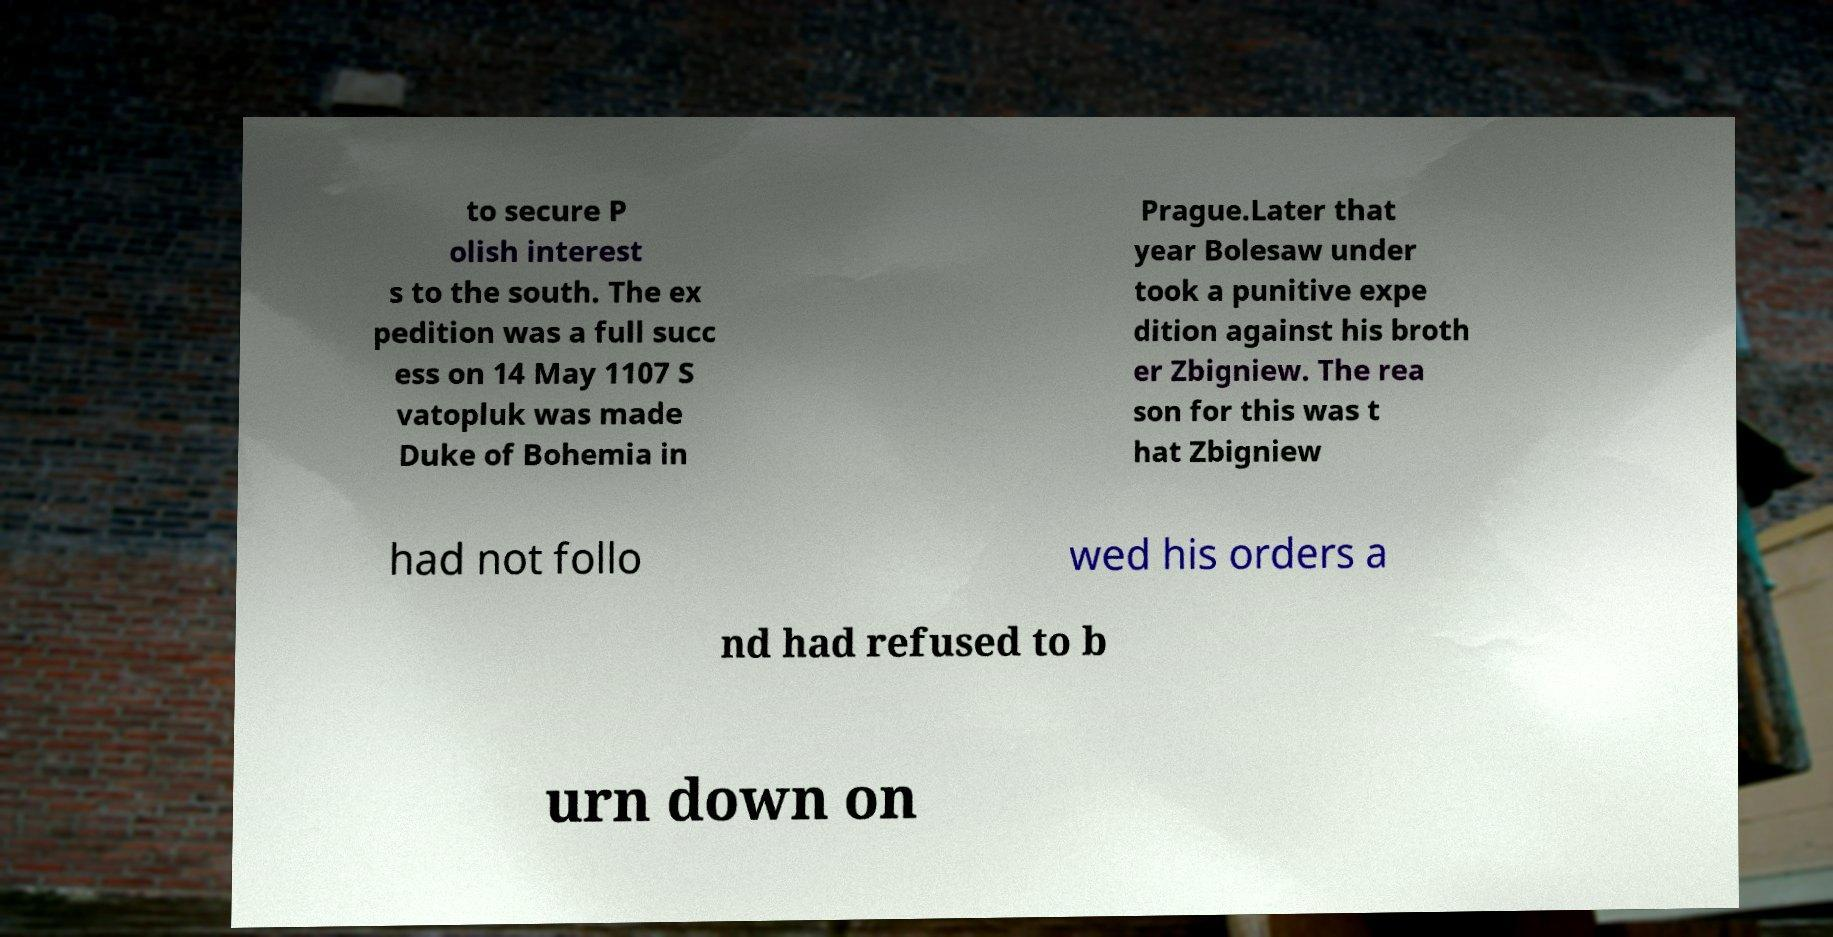There's text embedded in this image that I need extracted. Can you transcribe it verbatim? to secure P olish interest s to the south. The ex pedition was a full succ ess on 14 May 1107 S vatopluk was made Duke of Bohemia in Prague.Later that year Bolesaw under took a punitive expe dition against his broth er Zbigniew. The rea son for this was t hat Zbigniew had not follo wed his orders a nd had refused to b urn down on 